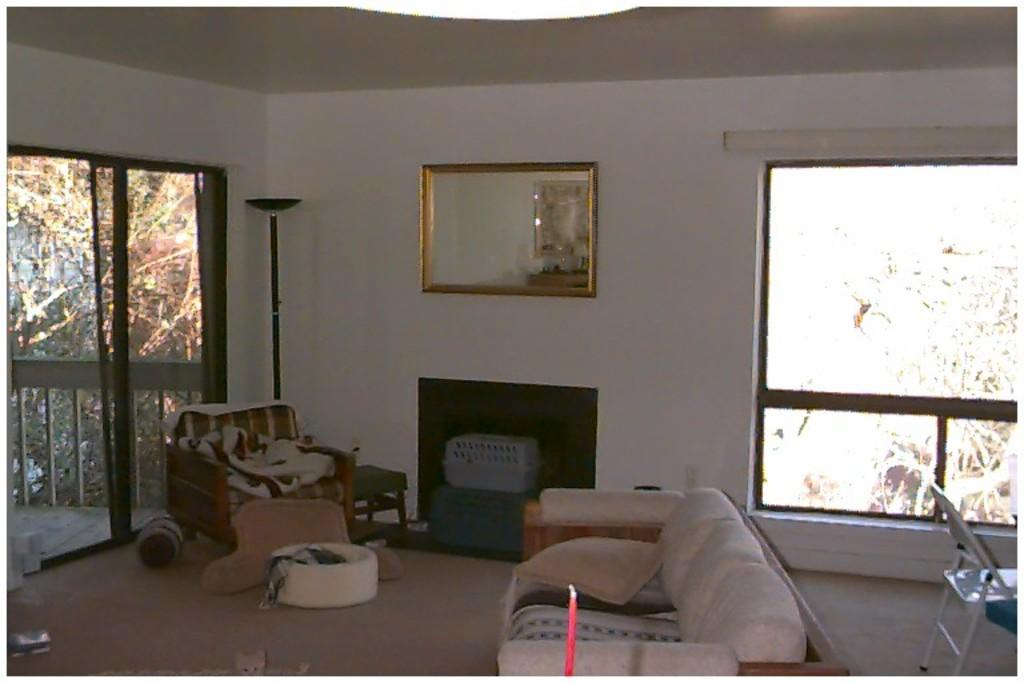What type of furniture is present in the image? There is a sofa and a chair in the image. Can you describe the decoration on the wall in the image? There is a photo frame on the wall in the image. How many people are participating in the feast in the image? There is no feast present in the image, so it is not possible to determine the number of participants. 